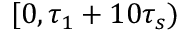Convert formula to latex. <formula><loc_0><loc_0><loc_500><loc_500>[ 0 , \tau _ { 1 } + 1 0 \tau _ { s } )</formula> 